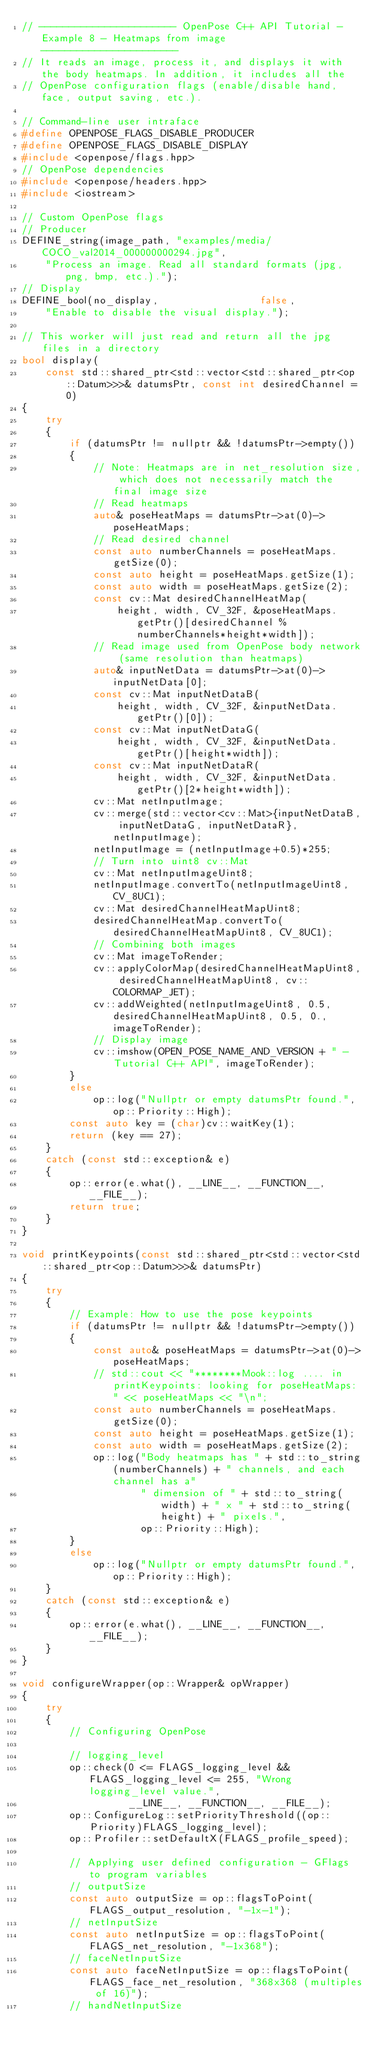Convert code to text. <code><loc_0><loc_0><loc_500><loc_500><_C++_>// ----------------------- OpenPose C++ API Tutorial - Example 8 - Heatmaps from image -----------------------
// It reads an image, process it, and displays it with the body heatmaps. In addition, it includes all the
// OpenPose configuration flags (enable/disable hand, face, output saving, etc.).

// Command-line user intraface
#define OPENPOSE_FLAGS_DISABLE_PRODUCER
#define OPENPOSE_FLAGS_DISABLE_DISPLAY
#include <openpose/flags.hpp>
// OpenPose dependencies
#include <openpose/headers.hpp>
#include <iostream>

// Custom OpenPose flags
// Producer
DEFINE_string(image_path, "examples/media/COCO_val2014_000000000294.jpg",
    "Process an image. Read all standard formats (jpg, png, bmp, etc.).");
// Display
DEFINE_bool(no_display,                 false,
    "Enable to disable the visual display.");

// This worker will just read and return all the jpg files in a directory
bool display(
    const std::shared_ptr<std::vector<std::shared_ptr<op::Datum>>>& datumsPtr, const int desiredChannel = 0)
{
    try
    {
        if (datumsPtr != nullptr && !datumsPtr->empty())
        {
            // Note: Heatmaps are in net_resolution size, which does not necessarily match the final image size
            // Read heatmaps
            auto& poseHeatMaps = datumsPtr->at(0)->poseHeatMaps;
            // Read desired channel
            const auto numberChannels = poseHeatMaps.getSize(0);
            const auto height = poseHeatMaps.getSize(1);
            const auto width = poseHeatMaps.getSize(2);
            const cv::Mat desiredChannelHeatMap(
                height, width, CV_32F, &poseHeatMaps.getPtr()[desiredChannel % numberChannels*height*width]);
            // Read image used from OpenPose body network (same resolution than heatmaps)
            auto& inputNetData = datumsPtr->at(0)->inputNetData[0];
            const cv::Mat inputNetDataB(
                height, width, CV_32F, &inputNetData.getPtr()[0]);
            const cv::Mat inputNetDataG(
                height, width, CV_32F, &inputNetData.getPtr()[height*width]);
            const cv::Mat inputNetDataR(
                height, width, CV_32F, &inputNetData.getPtr()[2*height*width]);
            cv::Mat netInputImage;
            cv::merge(std::vector<cv::Mat>{inputNetDataB, inputNetDataG, inputNetDataR}, netInputImage);
            netInputImage = (netInputImage+0.5)*255;
            // Turn into uint8 cv::Mat
            cv::Mat netInputImageUint8;
            netInputImage.convertTo(netInputImageUint8, CV_8UC1);
            cv::Mat desiredChannelHeatMapUint8;
            desiredChannelHeatMap.convertTo(desiredChannelHeatMapUint8, CV_8UC1);
            // Combining both images
            cv::Mat imageToRender;
            cv::applyColorMap(desiredChannelHeatMapUint8, desiredChannelHeatMapUint8, cv::COLORMAP_JET);
            cv::addWeighted(netInputImageUint8, 0.5, desiredChannelHeatMapUint8, 0.5, 0., imageToRender);
            // Display image
            cv::imshow(OPEN_POSE_NAME_AND_VERSION + " - Tutorial C++ API", imageToRender);
        }
        else
            op::log("Nullptr or empty datumsPtr found.", op::Priority::High);
        const auto key = (char)cv::waitKey(1);
        return (key == 27);
    }
    catch (const std::exception& e)
    {
        op::error(e.what(), __LINE__, __FUNCTION__, __FILE__);
        return true;
    }
}

void printKeypoints(const std::shared_ptr<std::vector<std::shared_ptr<op::Datum>>>& datumsPtr)
{
    try
    {
        // Example: How to use the pose keypoints
        if (datumsPtr != nullptr && !datumsPtr->empty())
        {
            const auto& poseHeatMaps = datumsPtr->at(0)->poseHeatMaps;
            // std::cout << "********Mook::log .... in printKeypoints: looking for poseHeatMaps: " << poseHeatMaps << "\n";
            const auto numberChannels = poseHeatMaps.getSize(0);
            const auto height = poseHeatMaps.getSize(1);
            const auto width = poseHeatMaps.getSize(2);
            op::log("Body heatmaps has " + std::to_string(numberChannels) + " channels, and each channel has a"
                    " dimension of " + std::to_string(width) + " x " + std::to_string(height) + " pixels.",
                    op::Priority::High);
        }
        else
            op::log("Nullptr or empty datumsPtr found.", op::Priority::High);
    }
    catch (const std::exception& e)
    {
        op::error(e.what(), __LINE__, __FUNCTION__, __FILE__);
    }
}

void configureWrapper(op::Wrapper& opWrapper)
{
    try
    {
        // Configuring OpenPose

        // logging_level
        op::check(0 <= FLAGS_logging_level && FLAGS_logging_level <= 255, "Wrong logging_level value.",
                  __LINE__, __FUNCTION__, __FILE__);
        op::ConfigureLog::setPriorityThreshold((op::Priority)FLAGS_logging_level);
        op::Profiler::setDefaultX(FLAGS_profile_speed);

        // Applying user defined configuration - GFlags to program variables
        // outputSize
        const auto outputSize = op::flagsToPoint(FLAGS_output_resolution, "-1x-1");
        // netInputSize
        const auto netInputSize = op::flagsToPoint(FLAGS_net_resolution, "-1x368");
        // faceNetInputSize
        const auto faceNetInputSize = op::flagsToPoint(FLAGS_face_net_resolution, "368x368 (multiples of 16)");
        // handNetInputSize</code> 